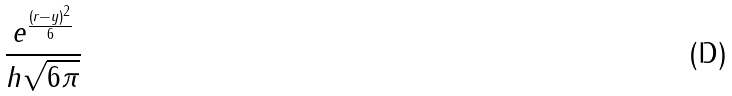<formula> <loc_0><loc_0><loc_500><loc_500>\frac { e ^ { \frac { ( r - y ) ^ { 2 } } { 6 } } } { h \sqrt { 6 \pi } }</formula> 